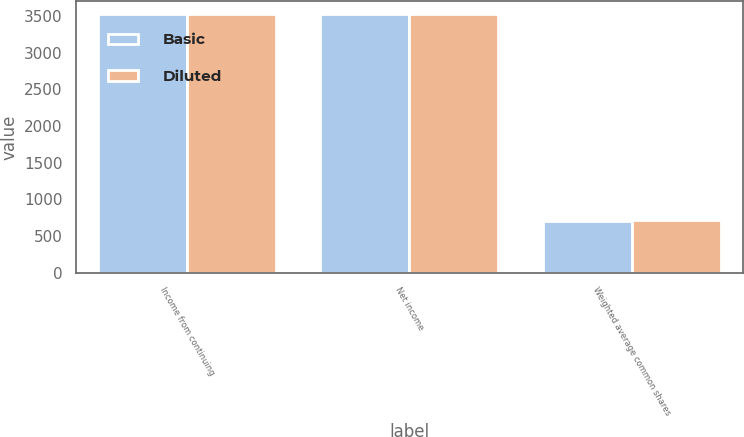Convert chart. <chart><loc_0><loc_0><loc_500><loc_500><stacked_bar_chart><ecel><fcel>Income from continuing<fcel>Net income<fcel>Weighted average common shares<nl><fcel>Basic<fcel>3528<fcel>3528<fcel>709<nl><fcel>Diluted<fcel>3528<fcel>3528<fcel>713<nl></chart> 